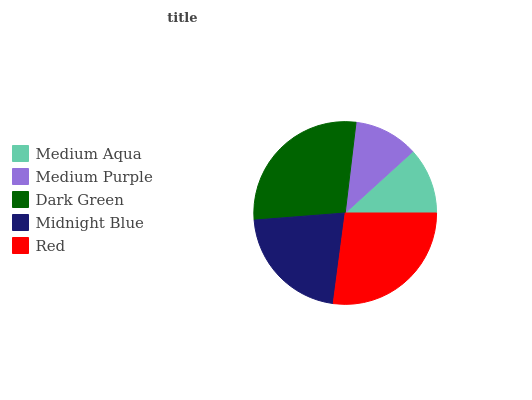Is Medium Purple the minimum?
Answer yes or no. Yes. Is Dark Green the maximum?
Answer yes or no. Yes. Is Dark Green the minimum?
Answer yes or no. No. Is Medium Purple the maximum?
Answer yes or no. No. Is Dark Green greater than Medium Purple?
Answer yes or no. Yes. Is Medium Purple less than Dark Green?
Answer yes or no. Yes. Is Medium Purple greater than Dark Green?
Answer yes or no. No. Is Dark Green less than Medium Purple?
Answer yes or no. No. Is Midnight Blue the high median?
Answer yes or no. Yes. Is Midnight Blue the low median?
Answer yes or no. Yes. Is Red the high median?
Answer yes or no. No. Is Red the low median?
Answer yes or no. No. 